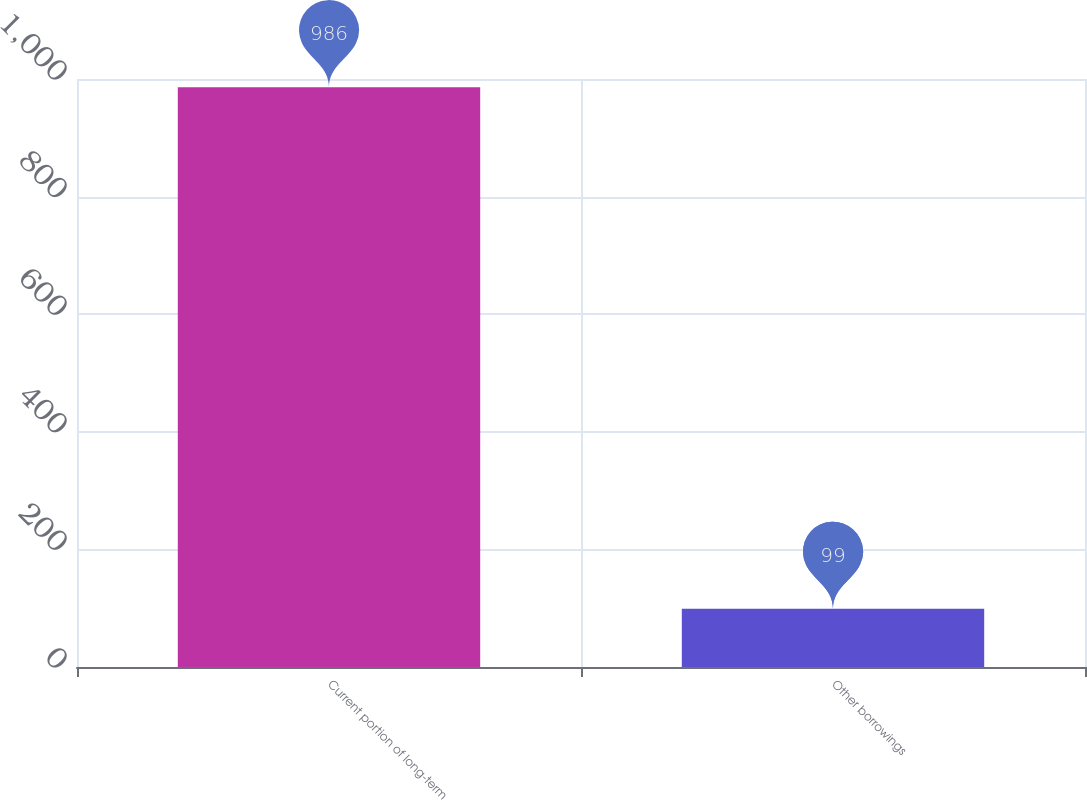Convert chart. <chart><loc_0><loc_0><loc_500><loc_500><bar_chart><fcel>Current portion of long-term<fcel>Other borrowings<nl><fcel>986<fcel>99<nl></chart> 